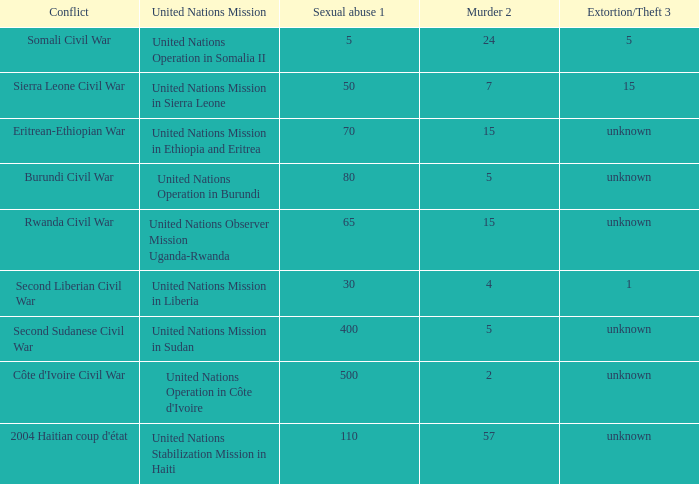What is the sexual abuse rate where the conflict is the Burundi Civil War? 80.0. 